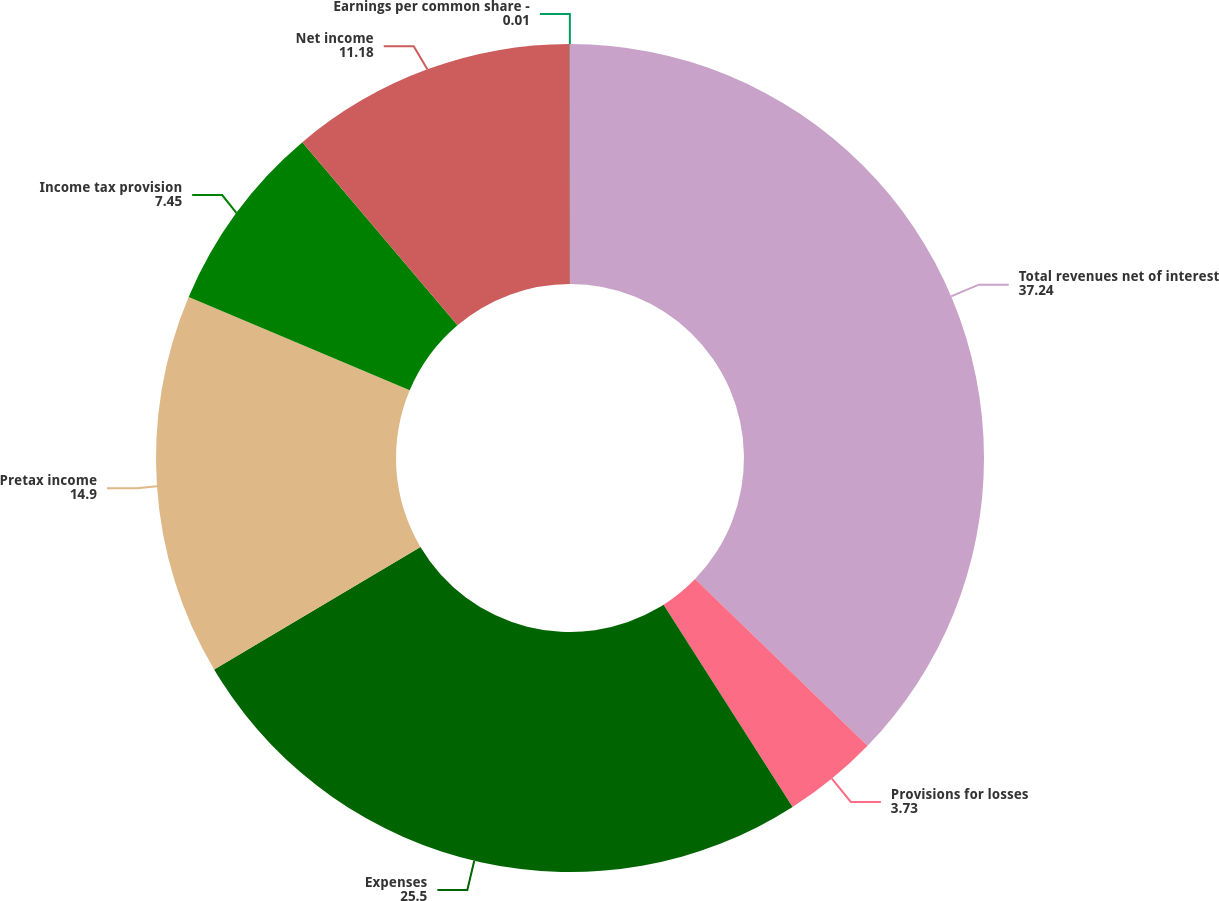Convert chart to OTSL. <chart><loc_0><loc_0><loc_500><loc_500><pie_chart><fcel>Total revenues net of interest<fcel>Provisions for losses<fcel>Expenses<fcel>Pretax income<fcel>Income tax provision<fcel>Net income<fcel>Earnings per common share -<nl><fcel>37.24%<fcel>3.73%<fcel>25.5%<fcel>14.9%<fcel>7.45%<fcel>11.18%<fcel>0.01%<nl></chart> 